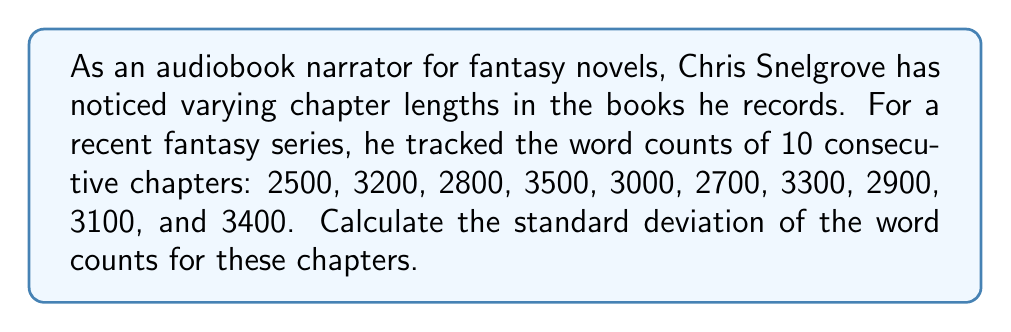Can you answer this question? To calculate the standard deviation, we'll follow these steps:

1. Calculate the mean (average) word count:
   $$\bar{x} = \frac{\sum_{i=1}^{n} x_i}{n} = \frac{2500 + 3200 + 2800 + 3500 + 3000 + 2700 + 3300 + 2900 + 3100 + 3400}{10} = 3040$$

2. Calculate the squared differences from the mean:
   $$(2500 - 3040)^2 = 291600$$
   $$(3200 - 3040)^2 = 25600$$
   $$(2800 - 3040)^2 = 57600$$
   $$(3500 - 3040)^2 = 211600$$
   $$(3000 - 3040)^2 = 1600$$
   $$(2700 - 3040)^2 = 115600$$
   $$(3300 - 3040)^2 = 67600$$
   $$(2900 - 3040)^2 = 19600$$
   $$(3100 - 3040)^2 = 3600$$
   $$(3400 - 3040)^2 = 129600$$

3. Sum the squared differences:
   $$\sum_{i=1}^{n} (x_i - \bar{x})^2 = 924000$$

4. Divide by $(n-1)$ to get the variance:
   $$s^2 = \frac{\sum_{i=1}^{n} (x_i - \bar{x})^2}{n-1} = \frac{924000}{9} = 102666.67$$

5. Take the square root of the variance to get the standard deviation:
   $$s = \sqrt{102666.67} \approx 320.42$$
Answer: The standard deviation of the word counts for these chapters is approximately 320.42 words. 